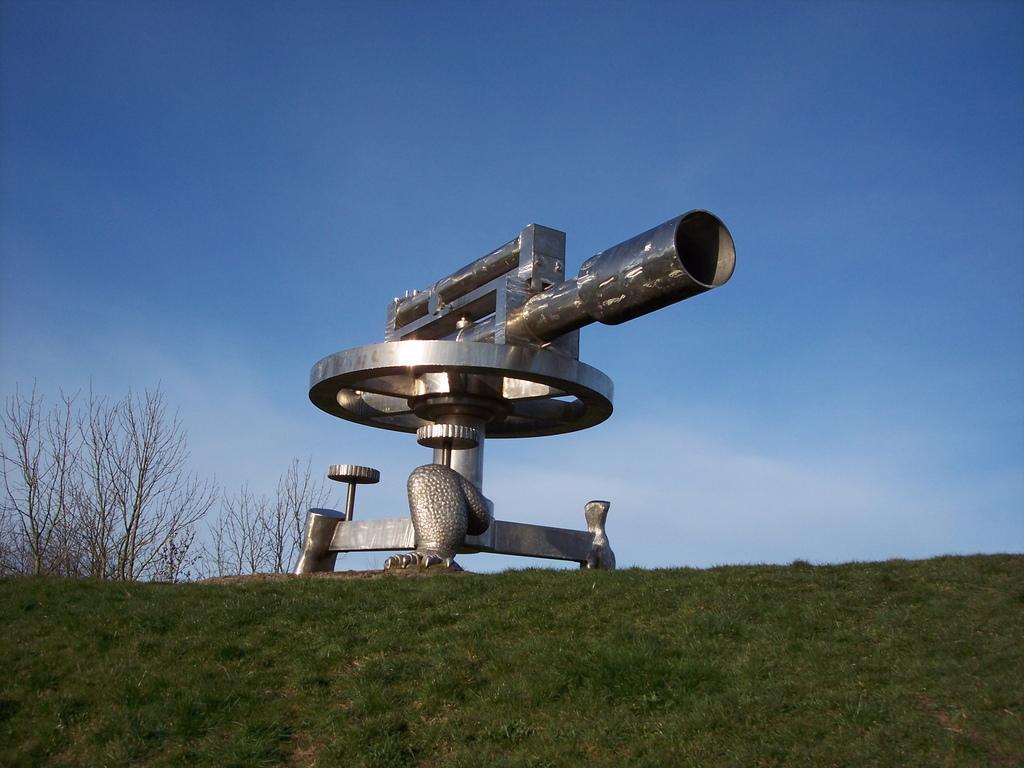Can you describe this image briefly? In the center of the image there is a statue. At the bottom there is a grass. In the background there is a sky and trees. 